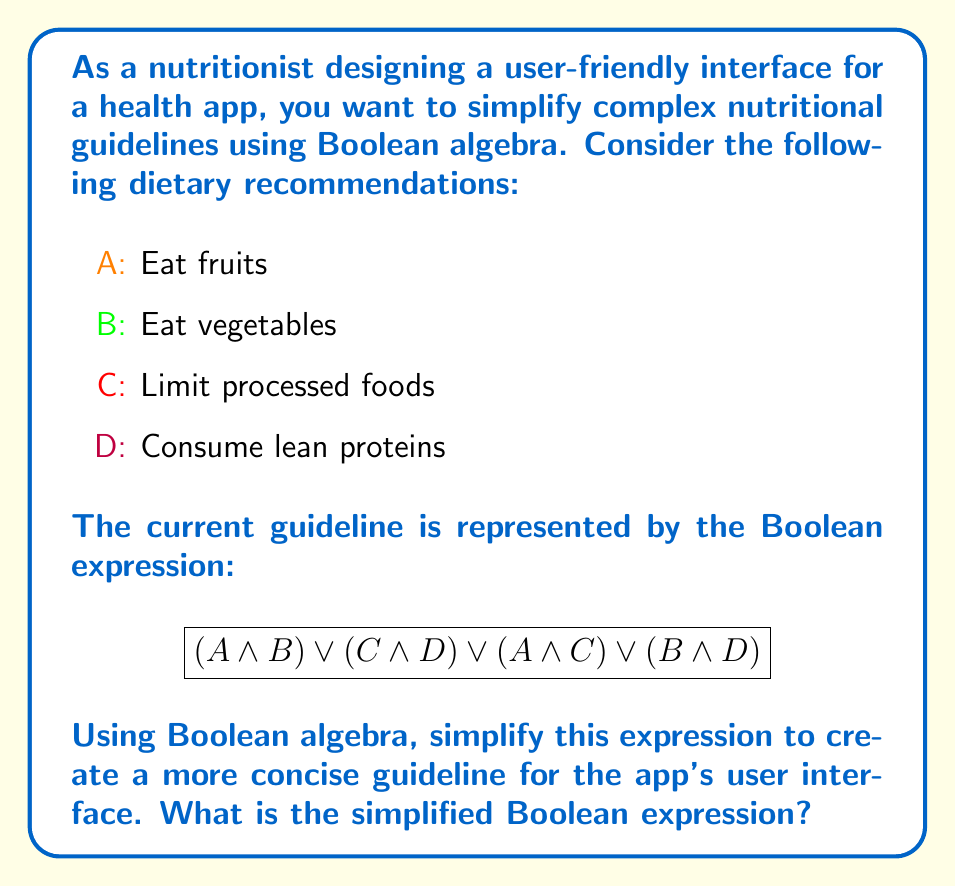Provide a solution to this math problem. Let's simplify the expression step by step using Boolean algebra laws:

1) Start with the original expression:
   $$(A \land B) \lor (C \land D) \lor (A \land C) \lor (B \land D)$$

2) Apply the distributive law to the first two terms:
   $$(A \land B) \lor (C \land D) = (A \lor C) \land (A \lor D) \land (B \lor C) \land (B \lor D)$$

3) Now our expression becomes:
   $$((A \lor C) \land (A \lor D) \land (B \lor C) \land (B \lor D)) \lor (A \land C) \lor (B \land D)$$

4) Apply the absorption law:
   $(X \land Y) \lor X = X$
   
   $(A \lor C) \land (A \land C) = A \lor C$
   $(B \lor D) \land (B \land D) = B \lor D$

5) After absorption, our expression simplifies to:
   $$(A \lor C) \land (B \lor D)$$

This simplified expression represents the same nutritional guideline in a more concise form, which is easier to implement in a user interface design.
Answer: $(A \lor C) \land (B \lor D)$ 